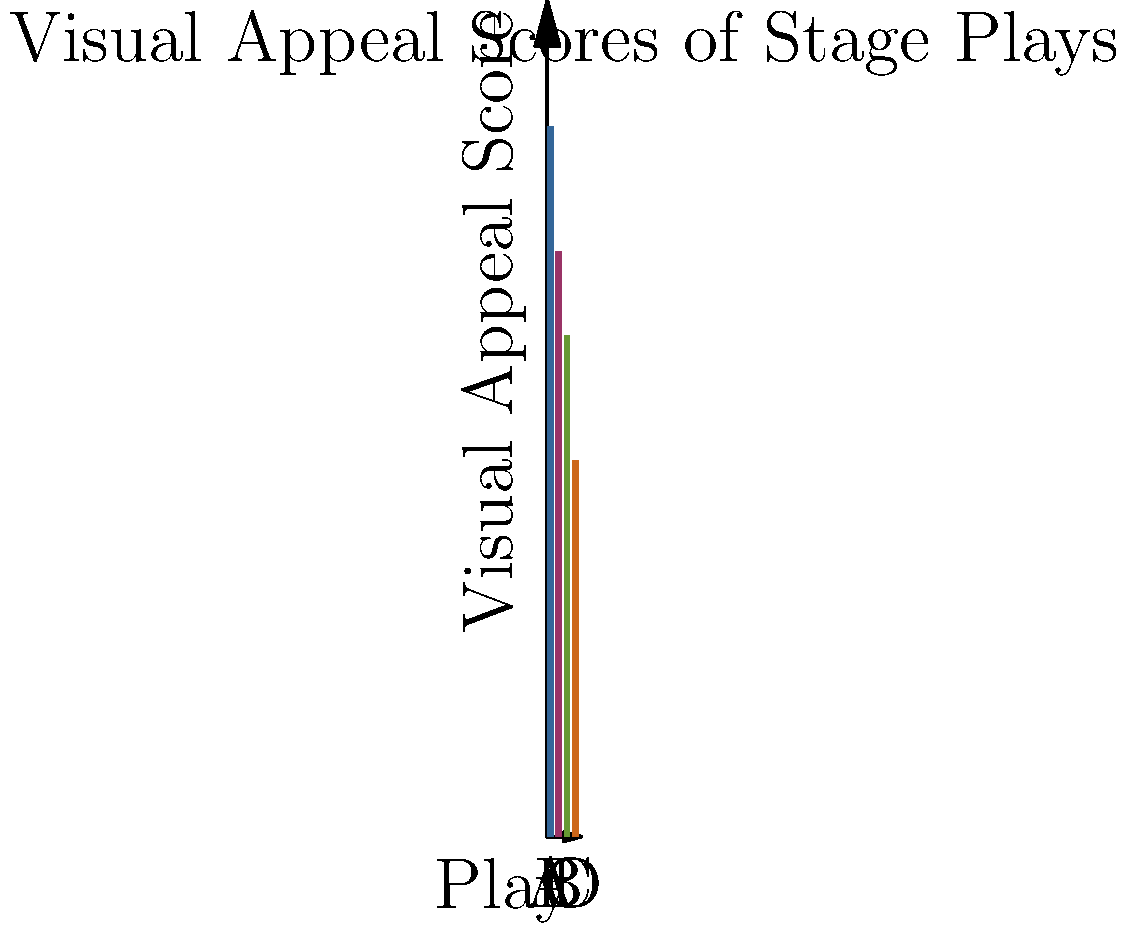Based on the graph showing the visual appeal scores of four stage plays (A, B, C, and D), which play should be prioritized for a film adaptation to maximize audience engagement through visual elements? To determine which play should be prioritized for a film adaptation based on visual elements, we need to analyze the visual appeal scores presented in the graph:

1. Play A: Has the highest visual appeal score of 85.
2. Play B: Has the second-highest score of 70.
3. Play C: Has a score of 60.
4. Play D: Has the lowest score of 45.

As a film executive looking to adapt a stage play for the screen, visual elements play a crucial role in engaging the audience and creating a visually stunning film. The higher the visual appeal score, the more likely the play is to translate well to the screen in terms of set design, costumes, and overall visual impact.

Given this information:

1. Play A, with the highest score of 85, offers the most potential for creating a visually appealing film adaptation.
2. It significantly outperforms the other plays in terms of visual elements.
3. A high visual appeal score suggests that the play already has strong visual components that can be further enhanced and expanded upon in a film adaptation.
4. This play is most likely to provide a solid foundation for creating visually engaging scenes, sets, and overall production design in the film version.

Therefore, to maximize audience engagement through visual elements, Play A should be prioritized for film adaptation.
Answer: Play A 